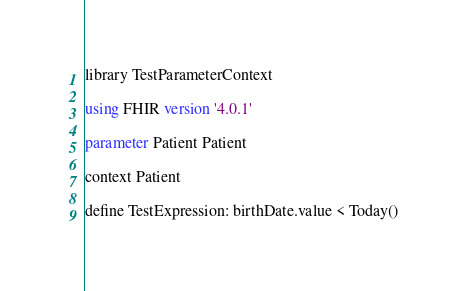<code> <loc_0><loc_0><loc_500><loc_500><_SQL_>library TestParameterContext

using FHIR version '4.0.1'

parameter Patient Patient

context Patient

define TestExpression: birthDate.value < Today()

</code> 